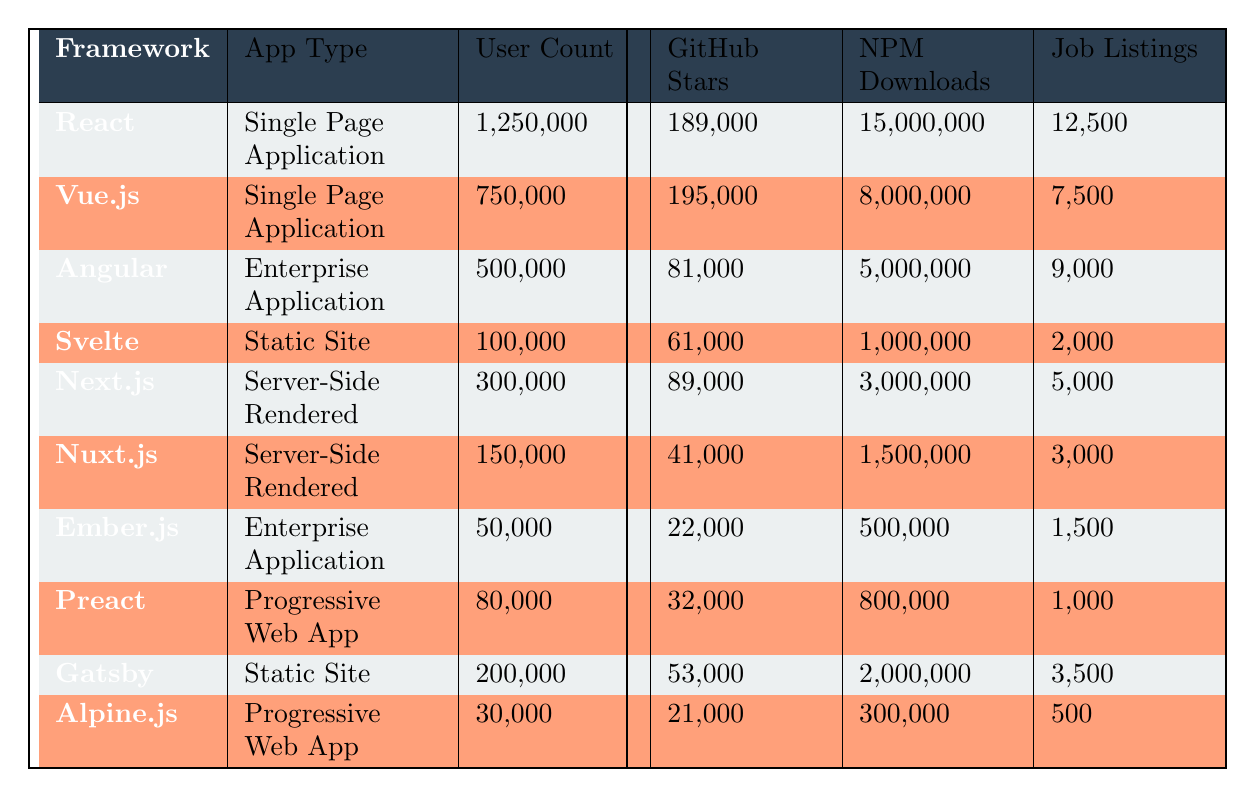What is the user count for the React framework? The user count for the React framework is listed directly in the table under the "User Count" column, which shows 1,250,000.
Answer: 1,250,000 How many job listings are there for Angular? The number of job listings for Angular is directly shown in the table under the "Job Listings" column, which is 9,000.
Answer: 9,000 Which framework has the highest GitHub stars? To find the framework with the highest GitHub stars, I can compare the values in the "GitHub Stars" column. React has 189,000 stars, and this is the highest amount in the table.
Answer: React What is the total number of users for frameworks that focus on Single Page Applications? The user counts for Single Page Applications are 1,250,000 for React and 750,000 for Vue.js. Adding these amounts together gives a total of 1,250,000 + 750,000 = 2,000,000.
Answer: 2,000,000 Is the learning curve for Ember.js steep? Looking at the "Learning Curve" column for Ember.js, it explicitly states "Steep," which confirms that the learning curve for Ember.js is indeed steep.
Answer: Yes Which framework has the lowest number of job listings, and what is that number? By examining the "Job Listings" column, I can see that Alpine.js has the lowest number of listings at 500.
Answer: Alpine.js, 500 What is the average number of GitHub stars for all frameworks listed? First, I will find the total GitHub stars: 189,000 (React) + 195,000 (Vue.js) + 81,000 (Angular) + 61,000 (Svelte) + 89,000 (Next.js) + 41,000 (Nuxt.js) + 22,000 (Ember.js) + 32,000 (Preact) + 53,000 (Gatsby) + 21,000 (Alpine.js) = 792,000. There are 10 frameworks, so I divide 792,000 by 10 to get the average: 792,000 / 10 = 79,200.
Answer: 79,200 What is the user count difference between Vue.js and Svelte? The user count for Vue.js is 750,000 and for Svelte is 100,000. The difference is calculated by subtracting the user count for Svelte from that of Vue.js: 750,000 - 100,000 = 650,000.
Answer: 650,000 Do Static Site frameworks have more user count on average than Progressive Web Apps? Static Site frameworks are Svelte (100,000) and Gatsby (200,000), giving an average of (100,000 + 200,000) / 2 = 150,000. Progressive Web App frameworks are Preact (80,000) and Alpine.js (30,000), giving an average of (80,000 + 30,000) / 2 = 55,000. Comparing both averages, 150,000 is greater than 55,000.
Answer: Yes 